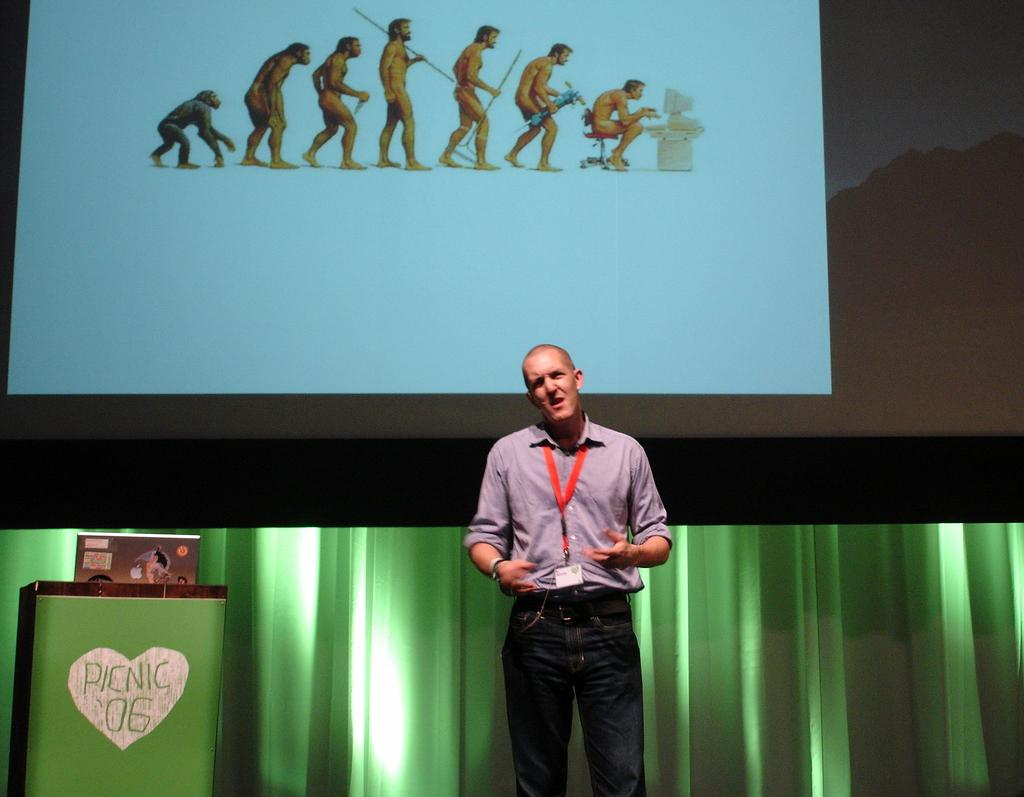What is the main subject of the image? There is a person standing in the image. What can be seen in the background of the image? There is a screen and a green color curtain in the background of the image. Where is the podium located in the image? The podium is on the left side of the image. What type of bread can be seen on the podium in the image? There is no bread present on the podium in the image. Can you tell me how many rifles are visible in the image? There are no rifles visible in the image. 